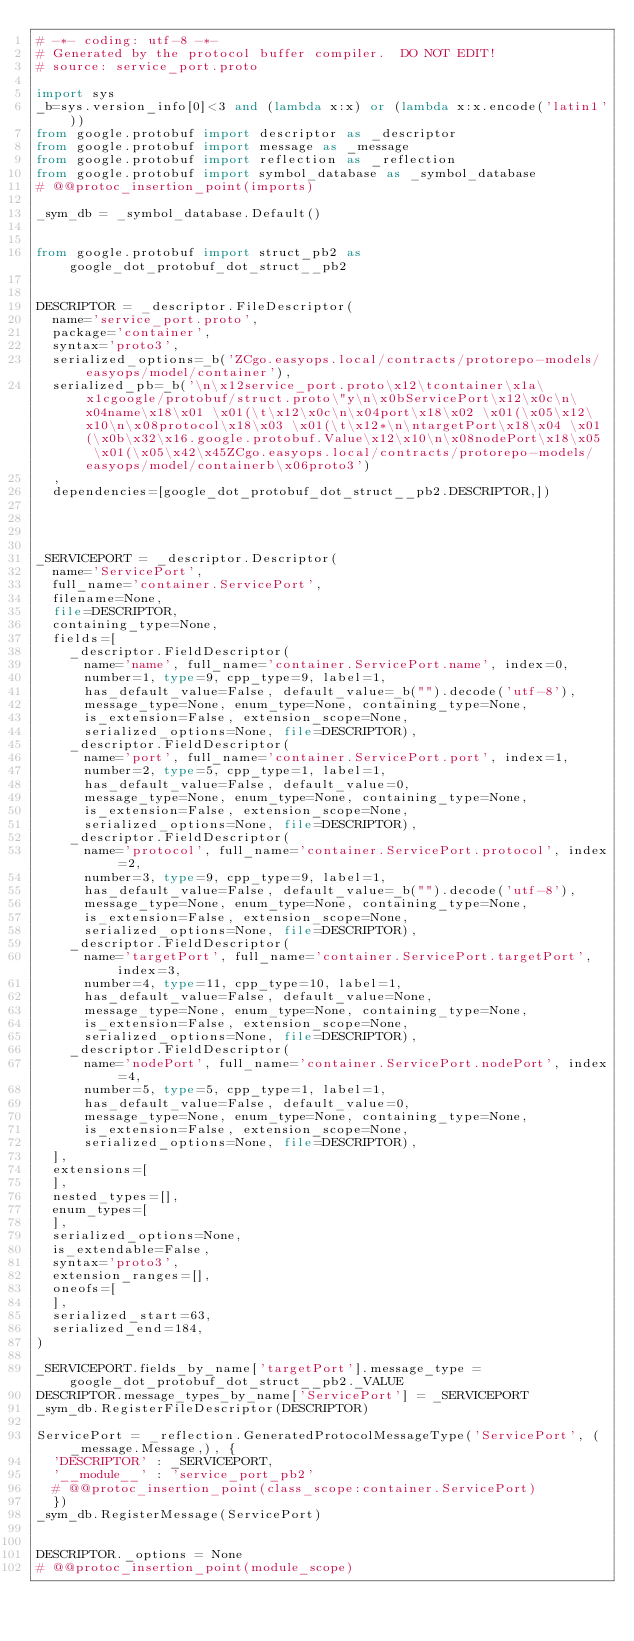<code> <loc_0><loc_0><loc_500><loc_500><_Python_># -*- coding: utf-8 -*-
# Generated by the protocol buffer compiler.  DO NOT EDIT!
# source: service_port.proto

import sys
_b=sys.version_info[0]<3 and (lambda x:x) or (lambda x:x.encode('latin1'))
from google.protobuf import descriptor as _descriptor
from google.protobuf import message as _message
from google.protobuf import reflection as _reflection
from google.protobuf import symbol_database as _symbol_database
# @@protoc_insertion_point(imports)

_sym_db = _symbol_database.Default()


from google.protobuf import struct_pb2 as google_dot_protobuf_dot_struct__pb2


DESCRIPTOR = _descriptor.FileDescriptor(
  name='service_port.proto',
  package='container',
  syntax='proto3',
  serialized_options=_b('ZCgo.easyops.local/contracts/protorepo-models/easyops/model/container'),
  serialized_pb=_b('\n\x12service_port.proto\x12\tcontainer\x1a\x1cgoogle/protobuf/struct.proto\"y\n\x0bServicePort\x12\x0c\n\x04name\x18\x01 \x01(\t\x12\x0c\n\x04port\x18\x02 \x01(\x05\x12\x10\n\x08protocol\x18\x03 \x01(\t\x12*\n\ntargetPort\x18\x04 \x01(\x0b\x32\x16.google.protobuf.Value\x12\x10\n\x08nodePort\x18\x05 \x01(\x05\x42\x45ZCgo.easyops.local/contracts/protorepo-models/easyops/model/containerb\x06proto3')
  ,
  dependencies=[google_dot_protobuf_dot_struct__pb2.DESCRIPTOR,])




_SERVICEPORT = _descriptor.Descriptor(
  name='ServicePort',
  full_name='container.ServicePort',
  filename=None,
  file=DESCRIPTOR,
  containing_type=None,
  fields=[
    _descriptor.FieldDescriptor(
      name='name', full_name='container.ServicePort.name', index=0,
      number=1, type=9, cpp_type=9, label=1,
      has_default_value=False, default_value=_b("").decode('utf-8'),
      message_type=None, enum_type=None, containing_type=None,
      is_extension=False, extension_scope=None,
      serialized_options=None, file=DESCRIPTOR),
    _descriptor.FieldDescriptor(
      name='port', full_name='container.ServicePort.port', index=1,
      number=2, type=5, cpp_type=1, label=1,
      has_default_value=False, default_value=0,
      message_type=None, enum_type=None, containing_type=None,
      is_extension=False, extension_scope=None,
      serialized_options=None, file=DESCRIPTOR),
    _descriptor.FieldDescriptor(
      name='protocol', full_name='container.ServicePort.protocol', index=2,
      number=3, type=9, cpp_type=9, label=1,
      has_default_value=False, default_value=_b("").decode('utf-8'),
      message_type=None, enum_type=None, containing_type=None,
      is_extension=False, extension_scope=None,
      serialized_options=None, file=DESCRIPTOR),
    _descriptor.FieldDescriptor(
      name='targetPort', full_name='container.ServicePort.targetPort', index=3,
      number=4, type=11, cpp_type=10, label=1,
      has_default_value=False, default_value=None,
      message_type=None, enum_type=None, containing_type=None,
      is_extension=False, extension_scope=None,
      serialized_options=None, file=DESCRIPTOR),
    _descriptor.FieldDescriptor(
      name='nodePort', full_name='container.ServicePort.nodePort', index=4,
      number=5, type=5, cpp_type=1, label=1,
      has_default_value=False, default_value=0,
      message_type=None, enum_type=None, containing_type=None,
      is_extension=False, extension_scope=None,
      serialized_options=None, file=DESCRIPTOR),
  ],
  extensions=[
  ],
  nested_types=[],
  enum_types=[
  ],
  serialized_options=None,
  is_extendable=False,
  syntax='proto3',
  extension_ranges=[],
  oneofs=[
  ],
  serialized_start=63,
  serialized_end=184,
)

_SERVICEPORT.fields_by_name['targetPort'].message_type = google_dot_protobuf_dot_struct__pb2._VALUE
DESCRIPTOR.message_types_by_name['ServicePort'] = _SERVICEPORT
_sym_db.RegisterFileDescriptor(DESCRIPTOR)

ServicePort = _reflection.GeneratedProtocolMessageType('ServicePort', (_message.Message,), {
  'DESCRIPTOR' : _SERVICEPORT,
  '__module__' : 'service_port_pb2'
  # @@protoc_insertion_point(class_scope:container.ServicePort)
  })
_sym_db.RegisterMessage(ServicePort)


DESCRIPTOR._options = None
# @@protoc_insertion_point(module_scope)
</code> 